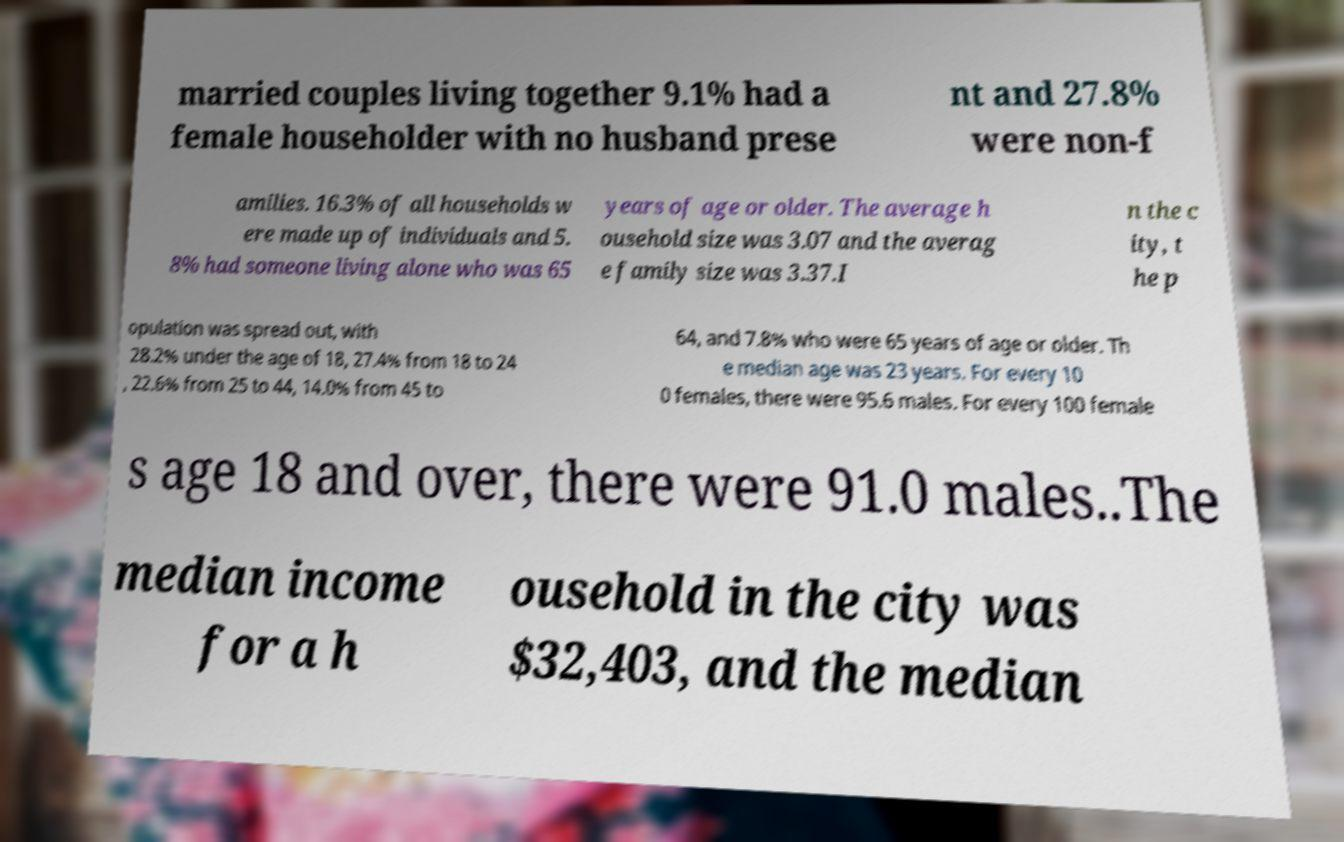What messages or text are displayed in this image? I need them in a readable, typed format. married couples living together 9.1% had a female householder with no husband prese nt and 27.8% were non-f amilies. 16.3% of all households w ere made up of individuals and 5. 8% had someone living alone who was 65 years of age or older. The average h ousehold size was 3.07 and the averag e family size was 3.37.I n the c ity, t he p opulation was spread out, with 28.2% under the age of 18, 27.4% from 18 to 24 , 22.6% from 25 to 44, 14.0% from 45 to 64, and 7.8% who were 65 years of age or older. Th e median age was 23 years. For every 10 0 females, there were 95.6 males. For every 100 female s age 18 and over, there were 91.0 males..The median income for a h ousehold in the city was $32,403, and the median 